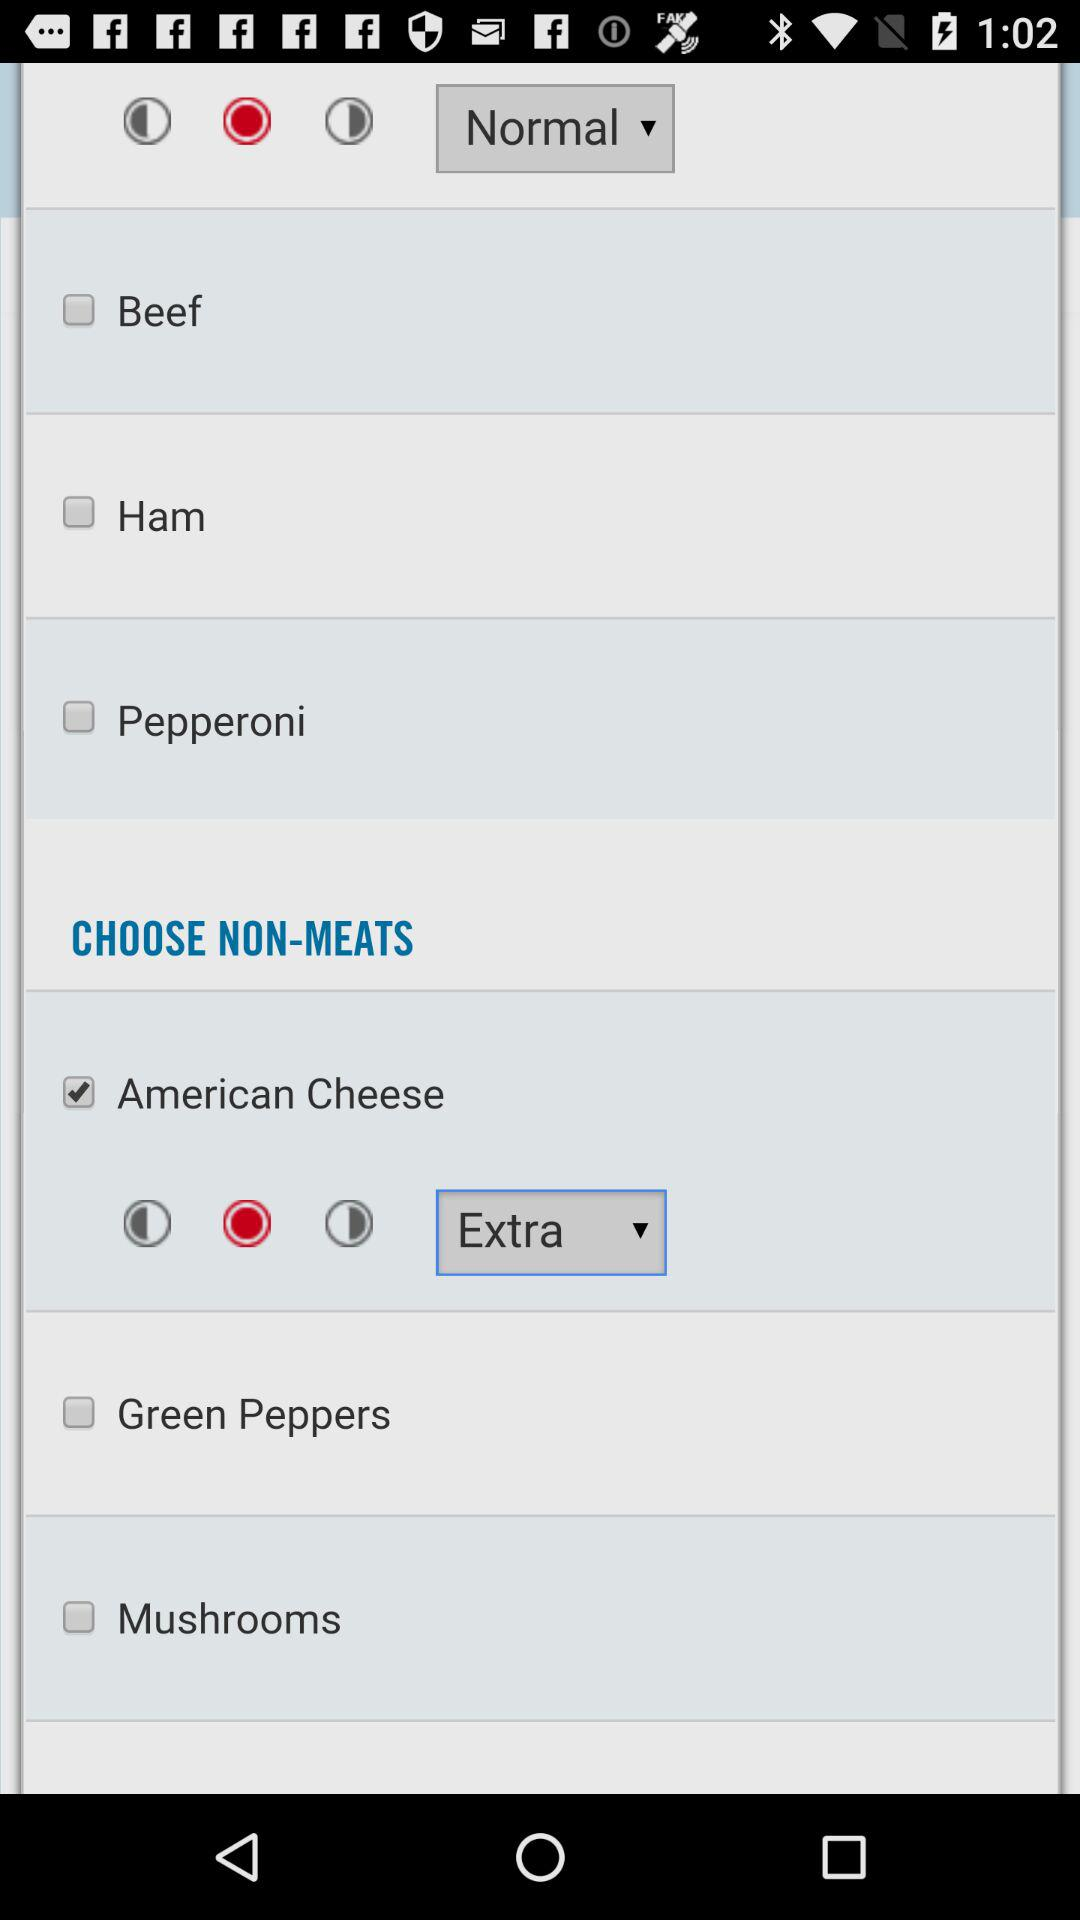What option is chosen for the quantity of "American Cheese"? The option chosen for the quantity of "American Cheese" is "Extra". 